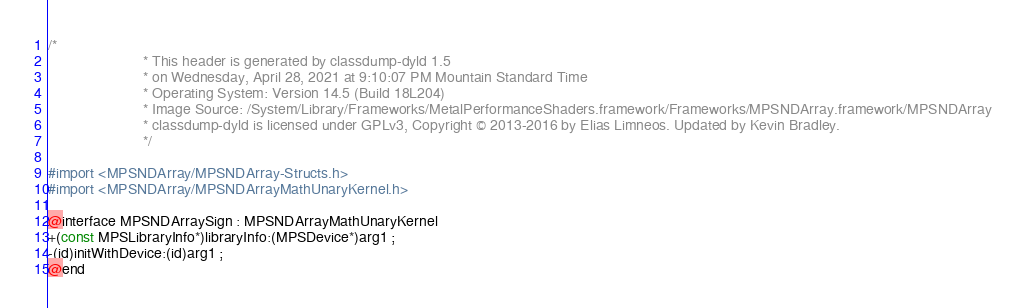Convert code to text. <code><loc_0><loc_0><loc_500><loc_500><_C_>/*
                       * This header is generated by classdump-dyld 1.5
                       * on Wednesday, April 28, 2021 at 9:10:07 PM Mountain Standard Time
                       * Operating System: Version 14.5 (Build 18L204)
                       * Image Source: /System/Library/Frameworks/MetalPerformanceShaders.framework/Frameworks/MPSNDArray.framework/MPSNDArray
                       * classdump-dyld is licensed under GPLv3, Copyright © 2013-2016 by Elias Limneos. Updated by Kevin Bradley.
                       */

#import <MPSNDArray/MPSNDArray-Structs.h>
#import <MPSNDArray/MPSNDArrayMathUnaryKernel.h>

@interface MPSNDArraySign : MPSNDArrayMathUnaryKernel
+(const MPSLibraryInfo*)libraryInfo:(MPSDevice*)arg1 ;
-(id)initWithDevice:(id)arg1 ;
@end

</code> 